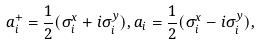Convert formula to latex. <formula><loc_0><loc_0><loc_500><loc_500>a _ { i } ^ { + } = \frac { 1 } { 2 } ( \sigma _ { i } ^ { x } + i \sigma _ { i } ^ { y } ) , a _ { i } = \frac { 1 } { 2 } ( \sigma _ { i } ^ { x } - i \sigma _ { i } ^ { y } ) ,</formula> 